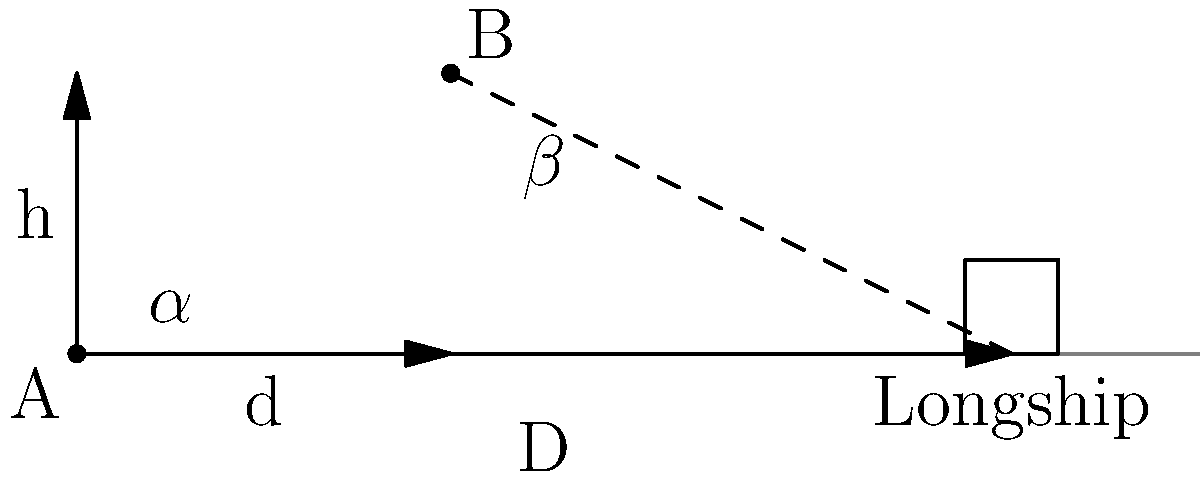As a nature photographer, you're tasked with capturing a Viking longship from two different positions. From point A on the ground, your camera's field of view creates an angle $\alpha$ with the longship. You then move to an elevated position B, which is at a height h = 3 meters and a horizontal distance d = 4 meters from A. From this new position, your camera's field of view creates an angle $\beta$ with the longship. If the longship is D = 10 meters away from point A, what is the difference between $\tan(\beta)$ and $\tan(\alpha)$? Let's approach this step-by-step:

1) First, let's calculate $\tan(\alpha)$:
   From point A, $\tan(\alpha) = \frac{\text{height of longship}}{\text{distance to longship}} = \frac{1}{10} = 0.1$

2) Now, let's calculate $\tan(\beta)$:
   From point B, we need to use the right triangle formed by B, its projection on the ground, and the longship.

3) The vertical side of this triangle is h = 3 meters.

4) The horizontal side is D - d = 10 - 4 = 6 meters.

5) Therefore, $\tan(\beta) = \frac{3}{6} = 0.5$

6) The difference between $\tan(\beta)$ and $\tan(\alpha)$ is:
   $\tan(\beta) - \tan(\alpha) = 0.5 - 0.1 = 0.4$

Thus, the difference between the tangents of the two angles is 0.4.
Answer: 0.4 